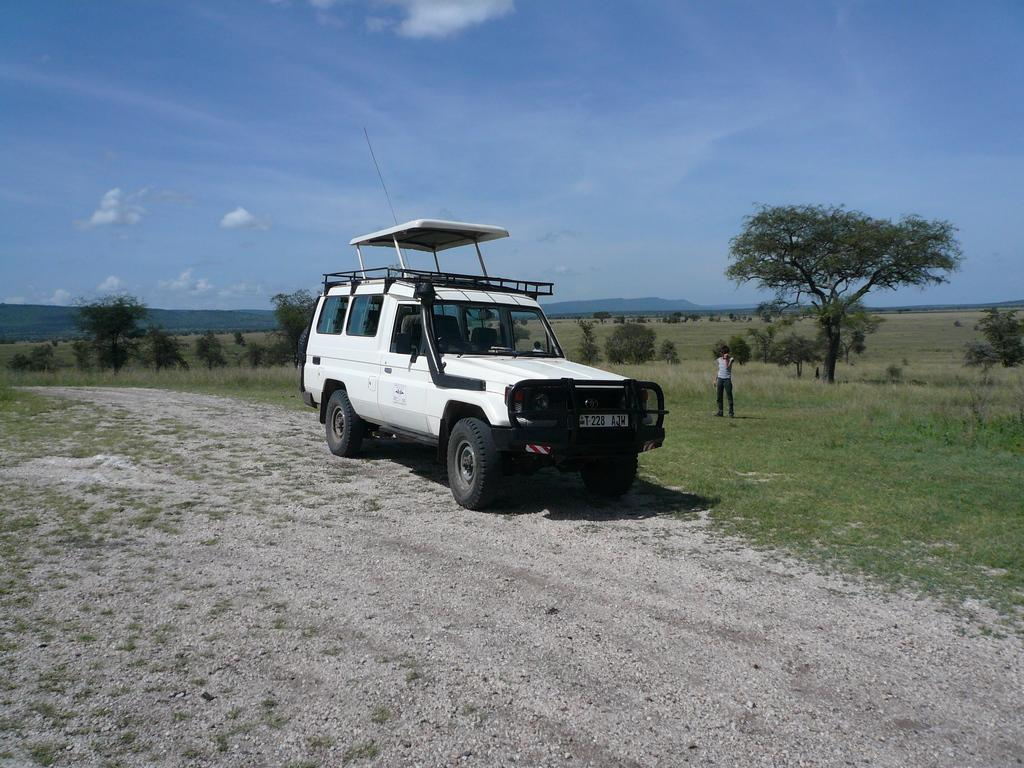What is the main subject in the center of the image? There is a vehicle in the center of the image. Can you describe the person in the image? There is a person standing on the right side of the image. What can be seen in the background of the image? There are trees, hills, and sky visible in the background of the image. What type of terrain is at the bottom of the image? There is grass at the bottom of the image. What type of patch is sewn onto the back of the person's shirt in the image? There is no patch or shirt visible in the image; the person is standing on the right side of the image. 